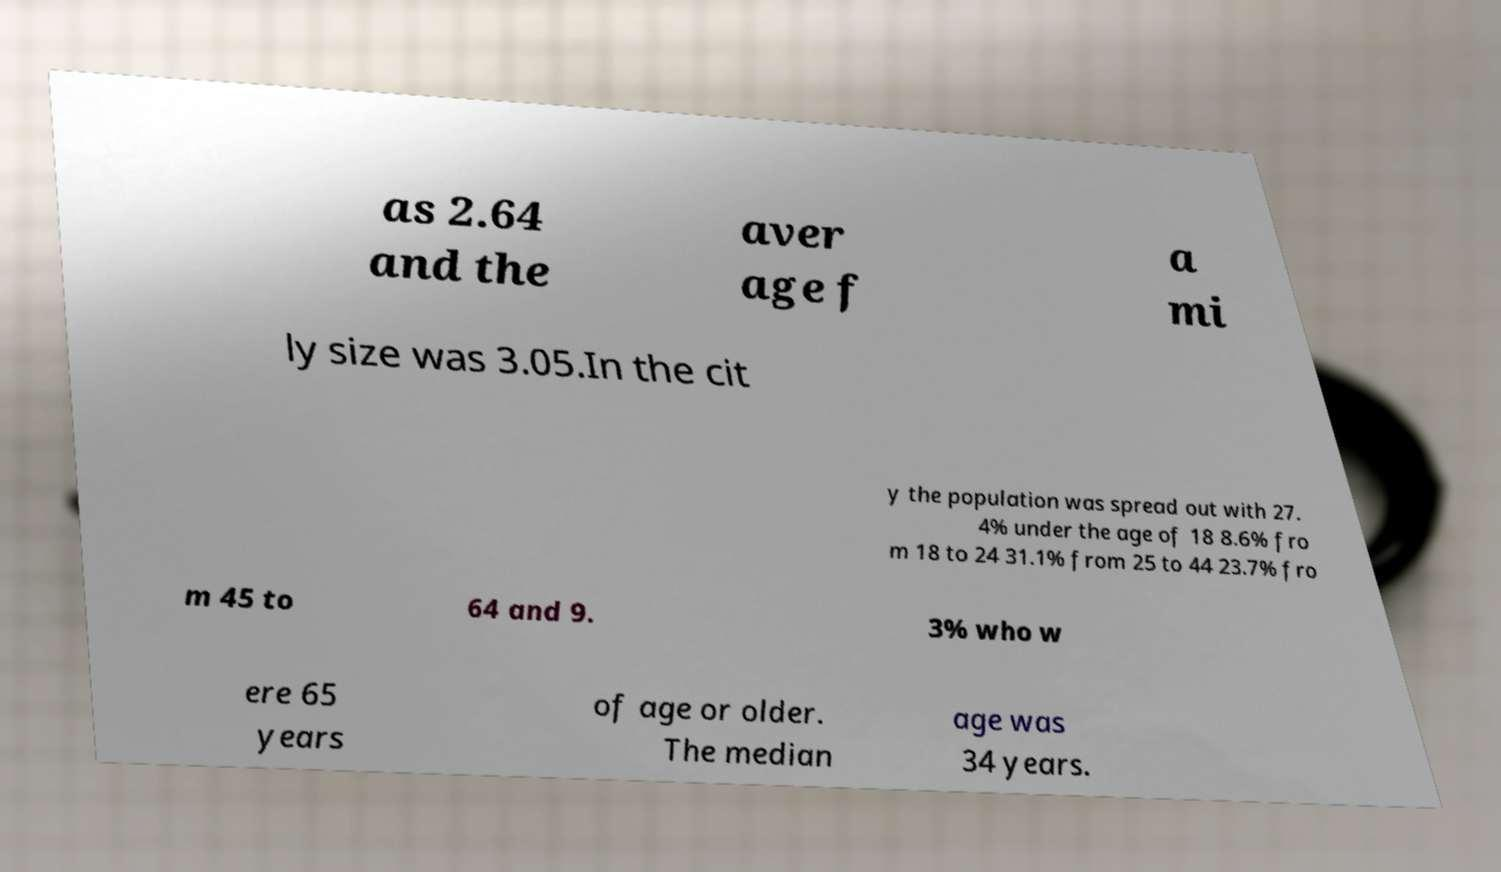Can you read and provide the text displayed in the image?This photo seems to have some interesting text. Can you extract and type it out for me? as 2.64 and the aver age f a mi ly size was 3.05.In the cit y the population was spread out with 27. 4% under the age of 18 8.6% fro m 18 to 24 31.1% from 25 to 44 23.7% fro m 45 to 64 and 9. 3% who w ere 65 years of age or older. The median age was 34 years. 